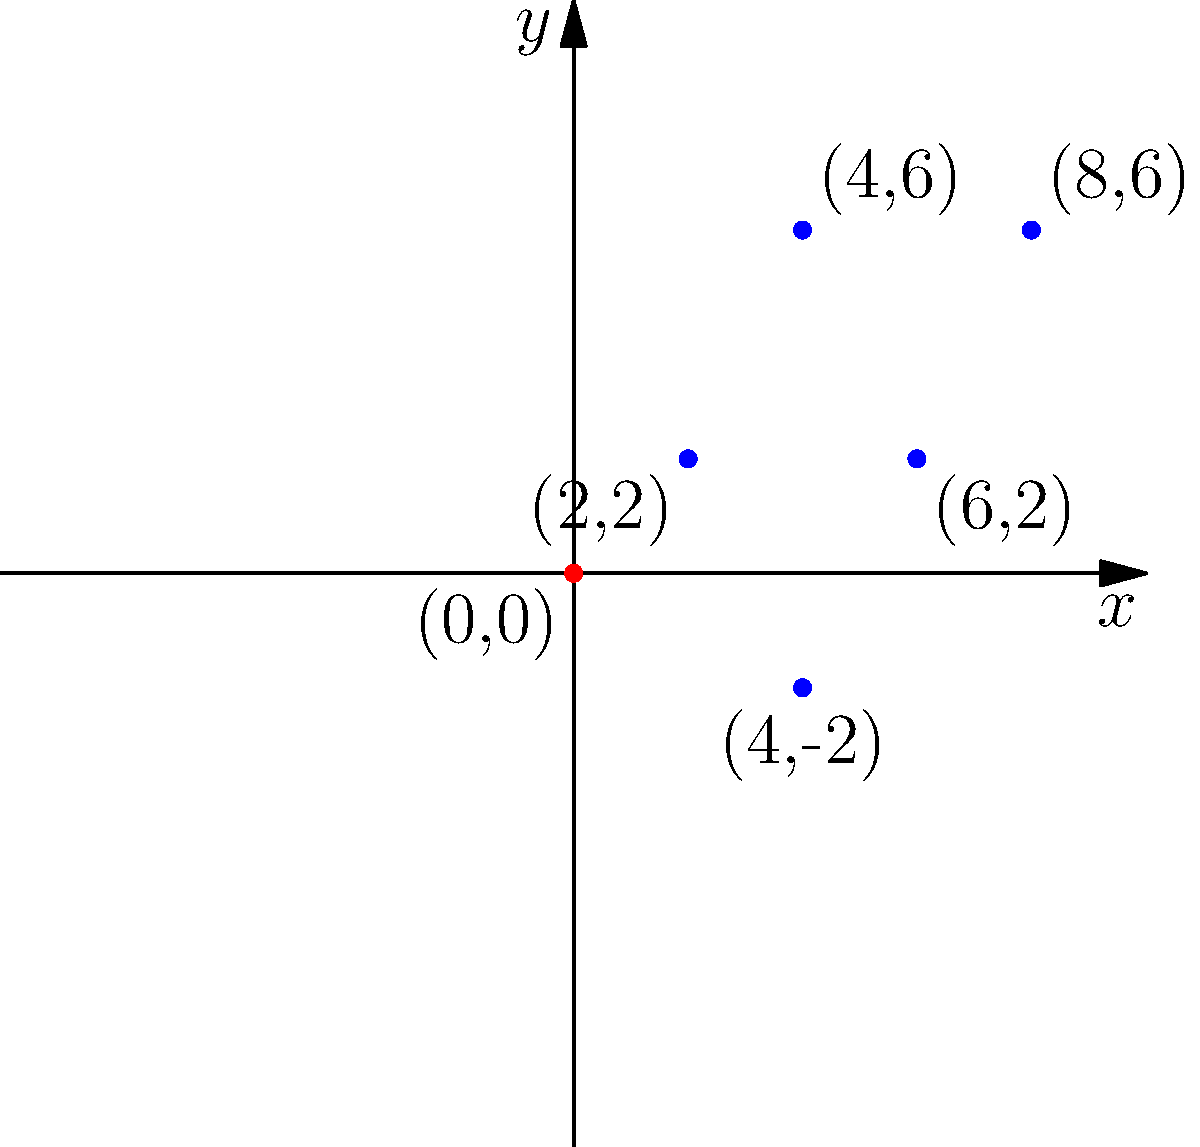As part of a project to design a new logo for your progressive school, you're tasked with plotting points on a Cartesian plane. The logo design consists of five key points that form a simple house shape, symbolizing education and growth. Given the following coordinates: (4,6), (8,6), (2,2), (6,2), and (4,-2), plot these points and connect them in the given order to create the logo. What geometric shape does the resulting figure resemble, and how does it relate to the school's vision of a well-rounded education? To answer this question, let's follow these steps:

1. Plot the given points on the Cartesian plane:
   - (4,6)
   - (8,6)
   - (2,2)
   - (6,2)
   - (4,-2)

2. Connect the points in the given order:
   - (4,6) to (8,6)
   - (8,6) to (2,2)
   - (2,2) to (6,2)
   - (6,2) to (4,-2)
   - (4,-2) to (4,6)

3. Analyze the resulting shape:
   - The top part (4,6) to (8,6) forms a horizontal line, representing the roof.
   - The sides (8,6) to (2,2) and (4,6) to (6,2) form slanted lines, representing the walls.
   - The bottom part (2,2) to (6,2) forms another horizontal line, representing the foundation.
   - The point (4,-2) extends below the foundation, forming a vertical line from (4,-2) to (4,6).

4. Interpret the shape:
   - The overall shape resembles a house with a flagpole.
   - The house structure symbolizes education as a foundation for growth and shelter for learning.
   - The flagpole represents achievement, aspiration, and the school's vision reaching beyond the basics.

5. Relate to the school's vision:
   - The house shape embodies the idea of a well-rounded education, with different parts representing various aspects of learning.
   - The roof symbolizes protection and nurturing of ideas.
   - The walls represent the supportive environment for learning.
   - The foundation signifies the basic skills and knowledge upon which further learning is built.
   - The flagpole extending beyond the house structure represents the school's progressive approach, encouraging students to reach beyond the conventional and aspire for higher achievements.
Answer: A house with a flagpole, symbolizing a well-rounded education (foundation), protection of ideas (roof), supportive learning environment (walls), and aspirations beyond conventional education (flagpole). 